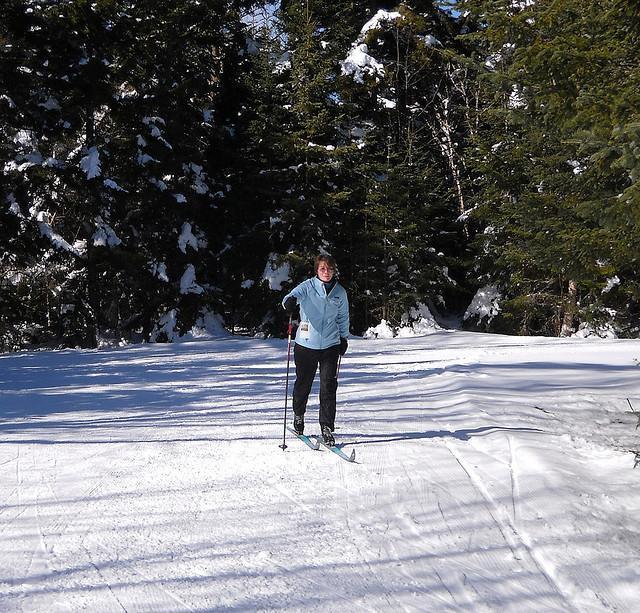How many skiers are there?
Give a very brief answer. 1. How many people are skiing?
Give a very brief answer. 1. How many dogs are standing in boat?
Give a very brief answer. 0. 